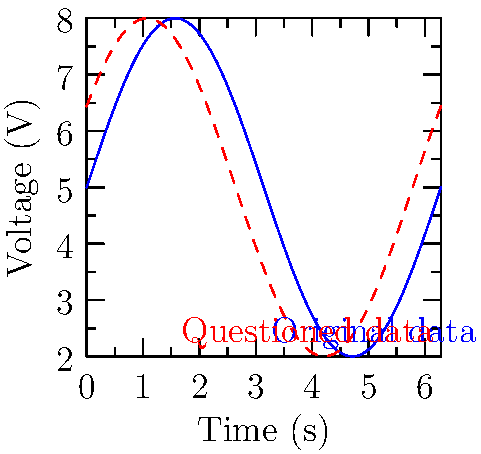A surveillance camera's footage timestamp is being challenged based on electronic data logs. The blue line represents the original voltage-time graph from the camera's power supply, while the red dashed line shows a slightly shifted version presented by the defense. If the period of the waveform is 2π seconds, what is the time difference (in seconds) between the two signals, and how might this impact the reliability of the timestamp? To determine the time difference between the two signals and its impact on the timestamp's reliability, we need to follow these steps:

1. Observe the graph: The red dashed line (questioned data) appears to be shifted to the left compared to the blue line (original data).

2. Identify the phase shift: The shift between the two signals represents a phase difference in the sinusoidal waveforms.

3. Calculate the phase difference: By comparing the two functions, we can see that the red line is represented by $f2(x) = 3\sin(x+0.5)+5$, while the blue line is $f1(x) = 3\sin(x)+5$. The phase difference is 0.5 radians.

4. Convert phase difference to time:
   Given: Period = 2π seconds
   Time shift = (Phase difference / 2π) × Period
   Time shift = (0.5 / 2π) × 2π = 0.5 seconds

5. Impact on timestamp reliability:
   A 0.5-second discrepancy in the power supply data could suggest:
   a) Potential tampering with the surveillance system
   b) Inaccuracy in the camera's internal clock
   c) Misalignment between the power supply data and the camera's timestamp

This time difference could be crucial in establishing or challenging the exact timing of events captured by the surveillance camera, potentially creating reasonable doubt about the accuracy of the timestamp and the reliability of the evidence.
Answer: 0.5 seconds; suggests possible timestamp inaccuracy or system tampering. 